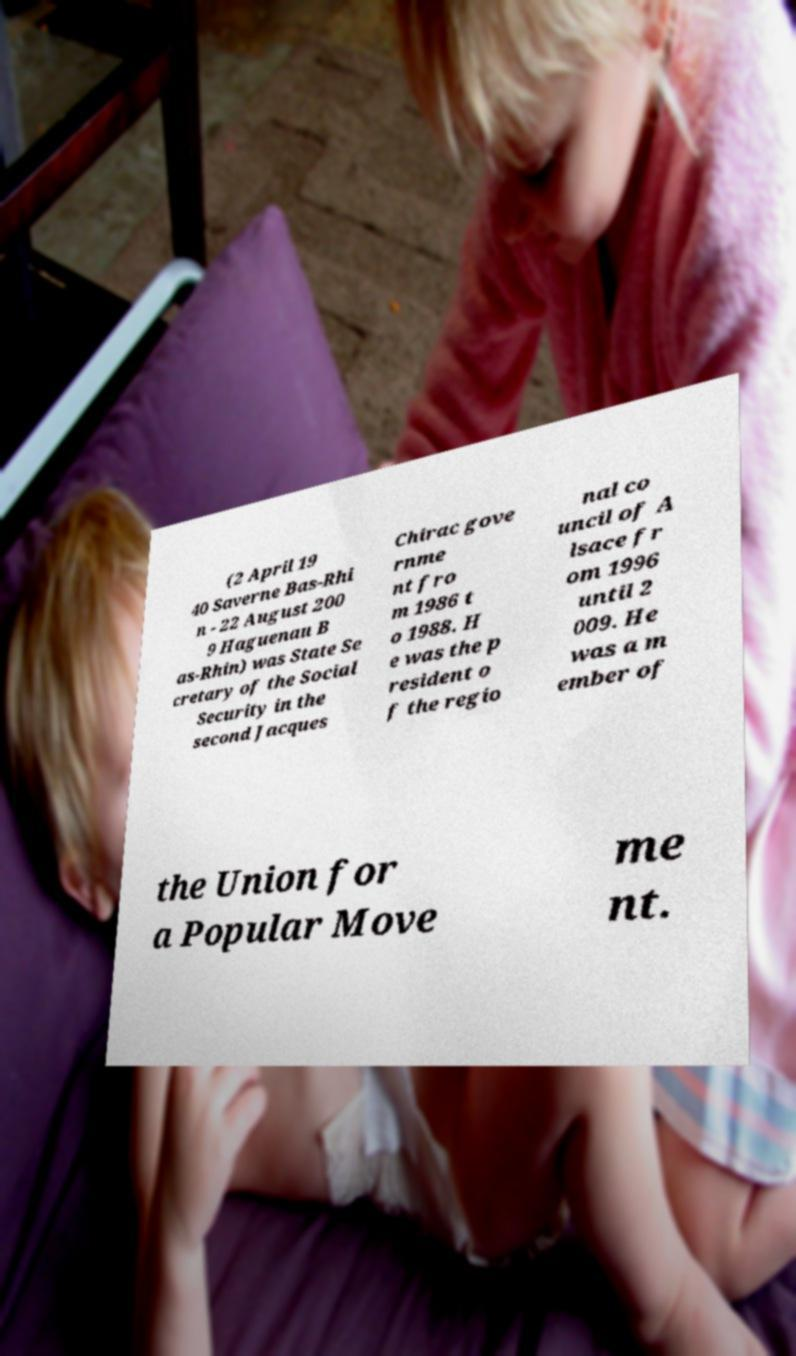Please identify and transcribe the text found in this image. (2 April 19 40 Saverne Bas-Rhi n - 22 August 200 9 Haguenau B as-Rhin) was State Se cretary of the Social Security in the second Jacques Chirac gove rnme nt fro m 1986 t o 1988. H e was the p resident o f the regio nal co uncil of A lsace fr om 1996 until 2 009. He was a m ember of the Union for a Popular Move me nt. 